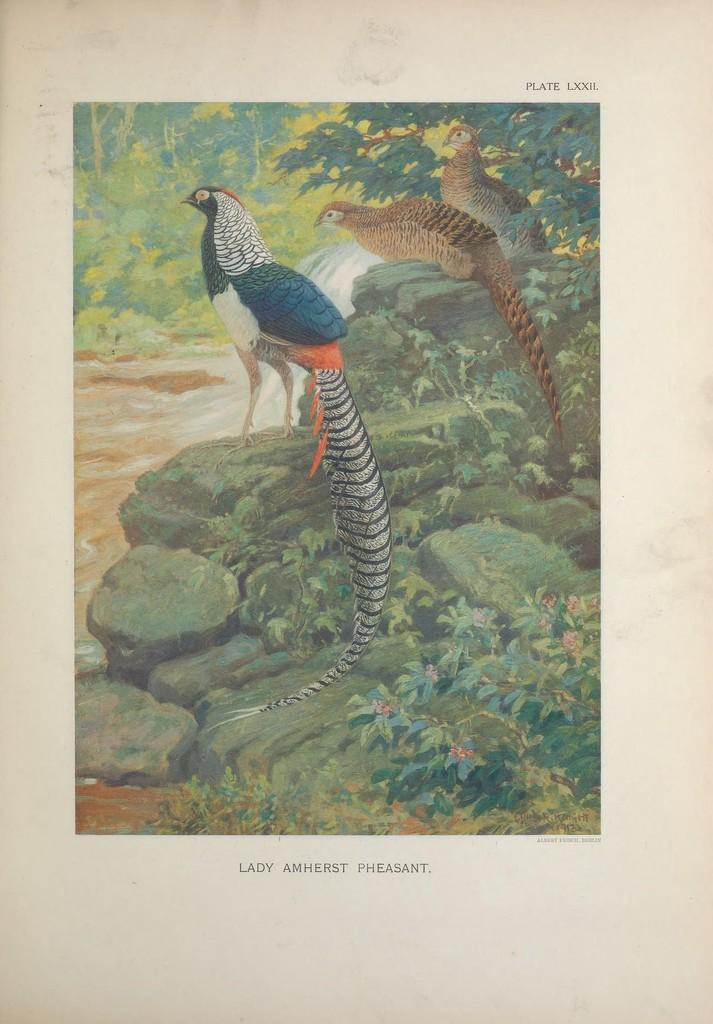What type of visual is the image? The image is a poster. What animals are featured in the foreground of the poster? There are peacocks in the foreground of the poster. Where are the peacocks standing in the image? The peacocks are standing on the side rocks of a river. What can be seen in the background of the poster? There are trees in the background of the poster. What type of amusement can be seen in the background of the poster? There is no amusement present in the image; it features peacocks standing on the side rocks of a river with trees in the background. What type of chain is holding the peacocks in the image? There is no chain present in the image; the peacocks are standing freely on the side rocks of a river. 